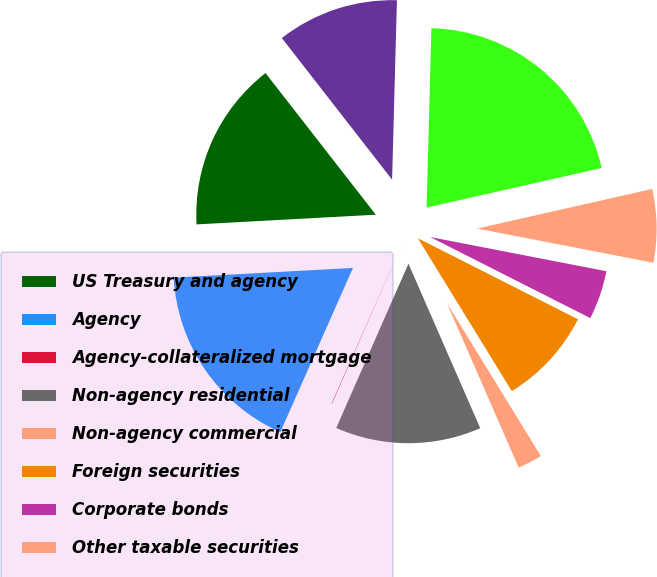<chart> <loc_0><loc_0><loc_500><loc_500><pie_chart><fcel>US Treasury and agency<fcel>Agency<fcel>Agency-collateralized mortgage<fcel>Non-agency residential<fcel>Non-agency commercial<fcel>Foreign securities<fcel>Corporate bonds<fcel>Other taxable securities<fcel>Total taxable securities<fcel>Tax-exempt securities (2)<nl><fcel>15.33%<fcel>17.51%<fcel>0.04%<fcel>13.14%<fcel>2.22%<fcel>8.77%<fcel>4.41%<fcel>6.59%<fcel>21.03%<fcel>10.96%<nl></chart> 